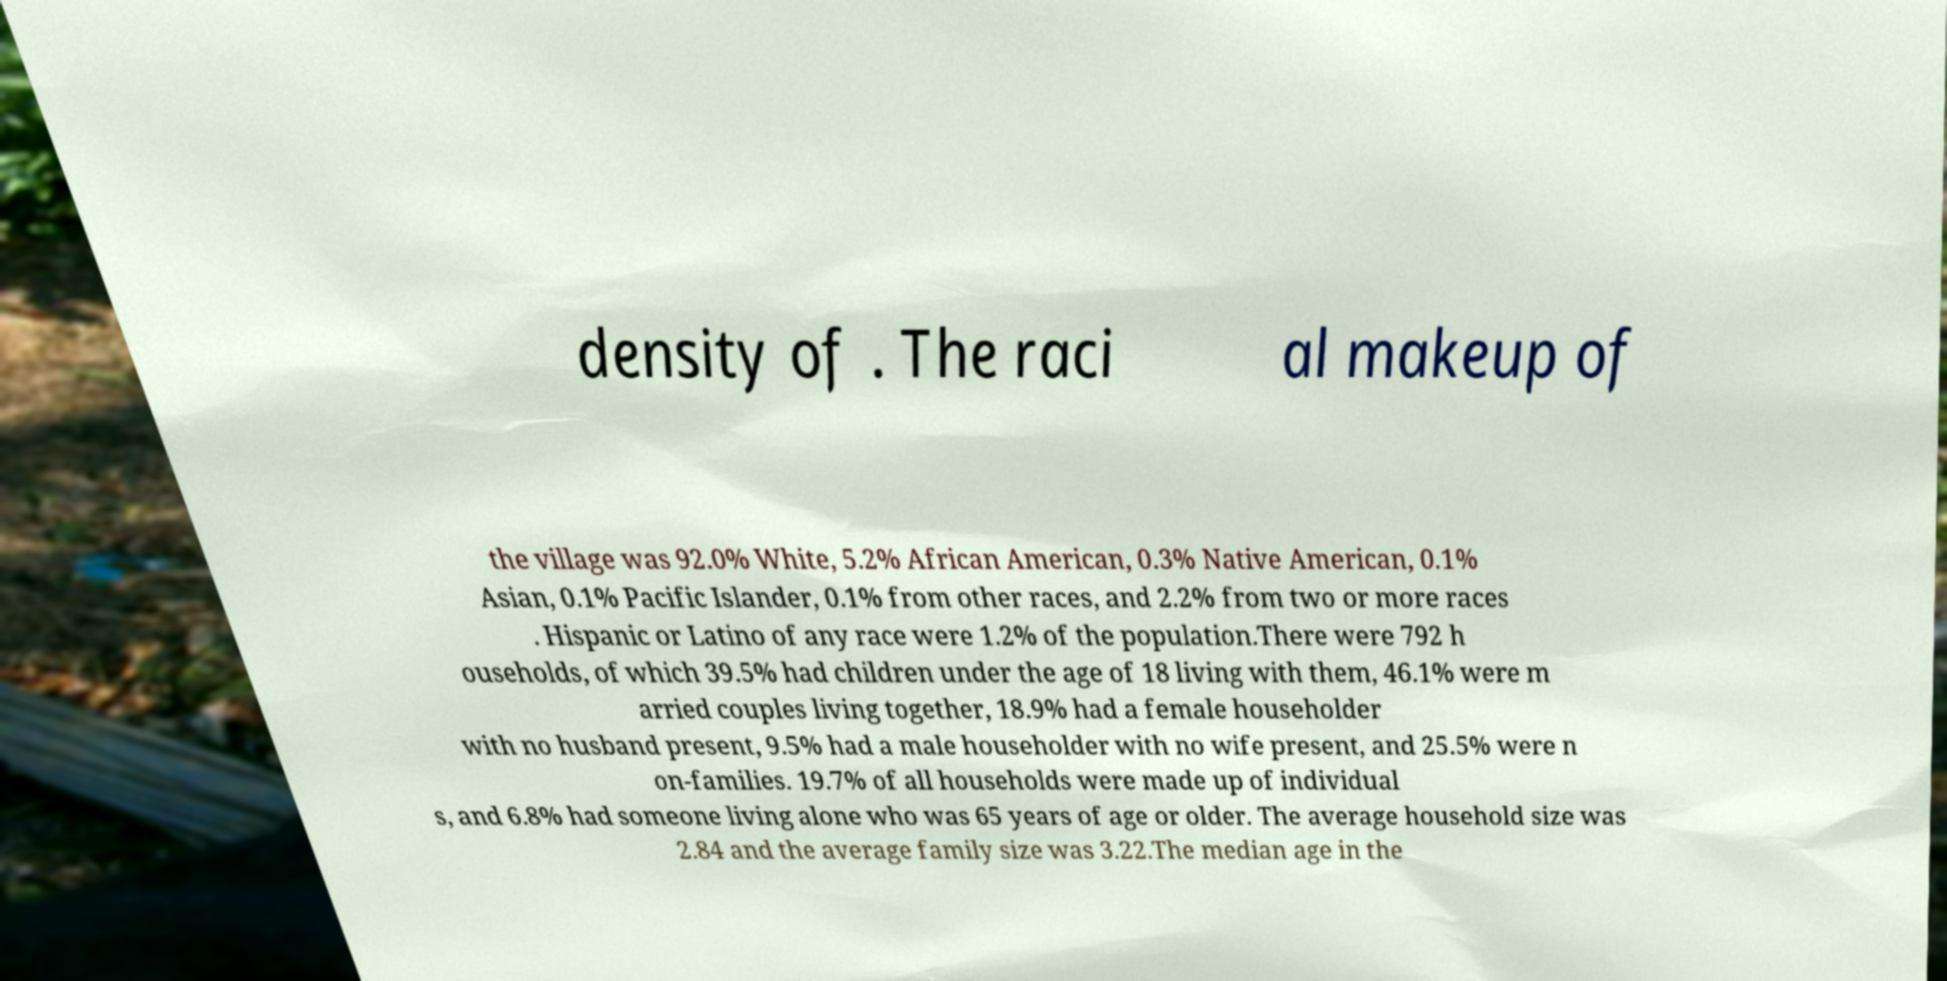What messages or text are displayed in this image? I need them in a readable, typed format. density of . The raci al makeup of the village was 92.0% White, 5.2% African American, 0.3% Native American, 0.1% Asian, 0.1% Pacific Islander, 0.1% from other races, and 2.2% from two or more races . Hispanic or Latino of any race were 1.2% of the population.There were 792 h ouseholds, of which 39.5% had children under the age of 18 living with them, 46.1% were m arried couples living together, 18.9% had a female householder with no husband present, 9.5% had a male householder with no wife present, and 25.5% were n on-families. 19.7% of all households were made up of individual s, and 6.8% had someone living alone who was 65 years of age or older. The average household size was 2.84 and the average family size was 3.22.The median age in the 